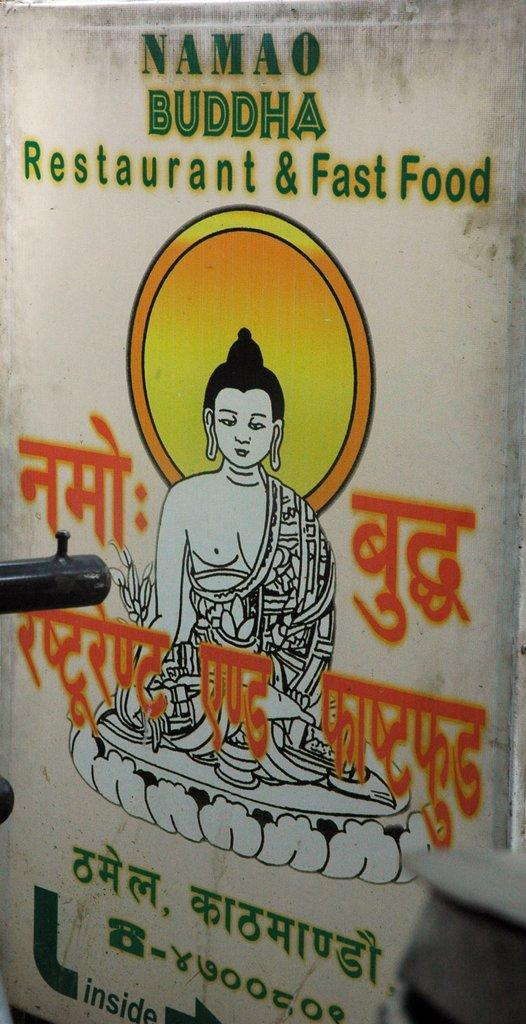What is featured in the image? There is a poster in the image. What is the purpose of the poster? The poster is an advertisement for a restaurant and fast food. What image is included on the poster? There is a painting of Lord Buddha on the poster. What type of flower is depicted in the painting of Lord Buddha on the poster? There is no flower depicted in the painting of Lord Buddha on the poster. 